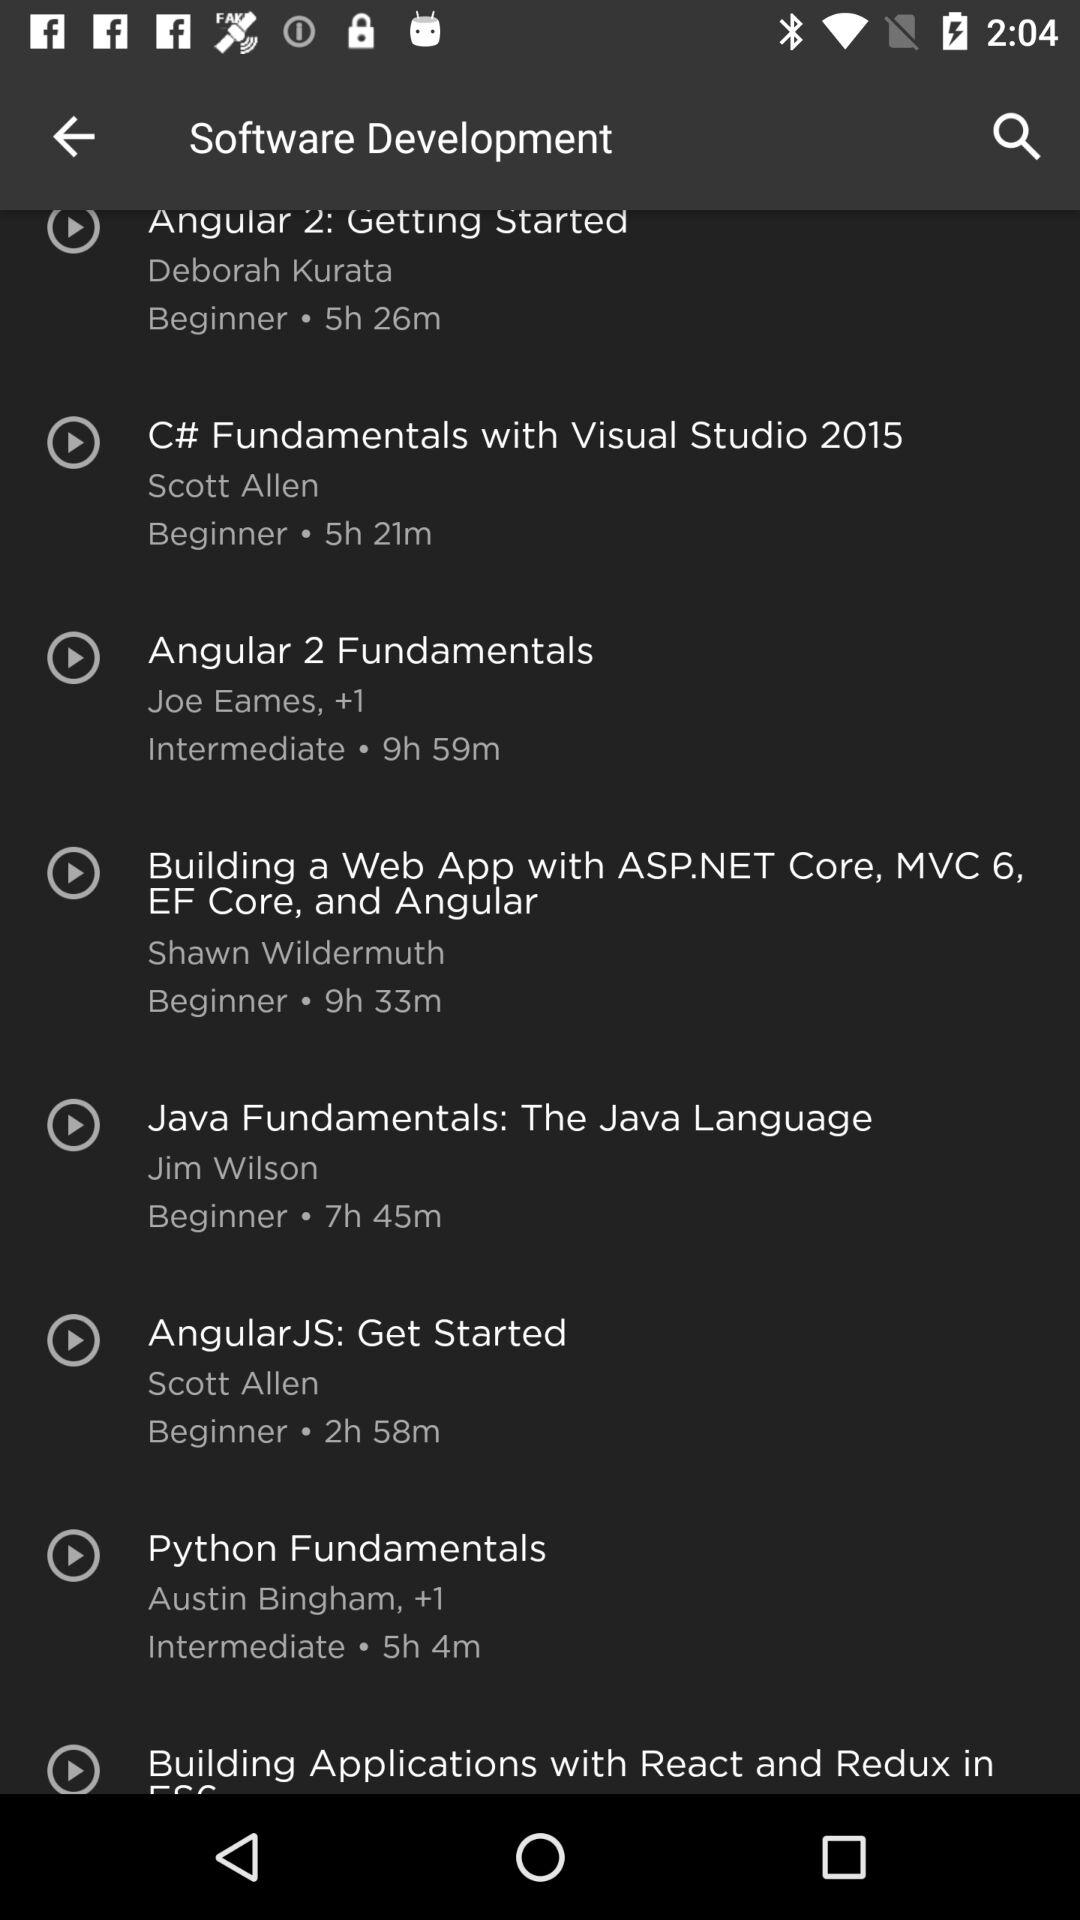What is the duration of the "Angular 2 Fundamentals" course? The duration is 9 hours and 59 minutes. 